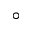<formula> <loc_0><loc_0><loc_500><loc_500>^ { \circ }</formula> 